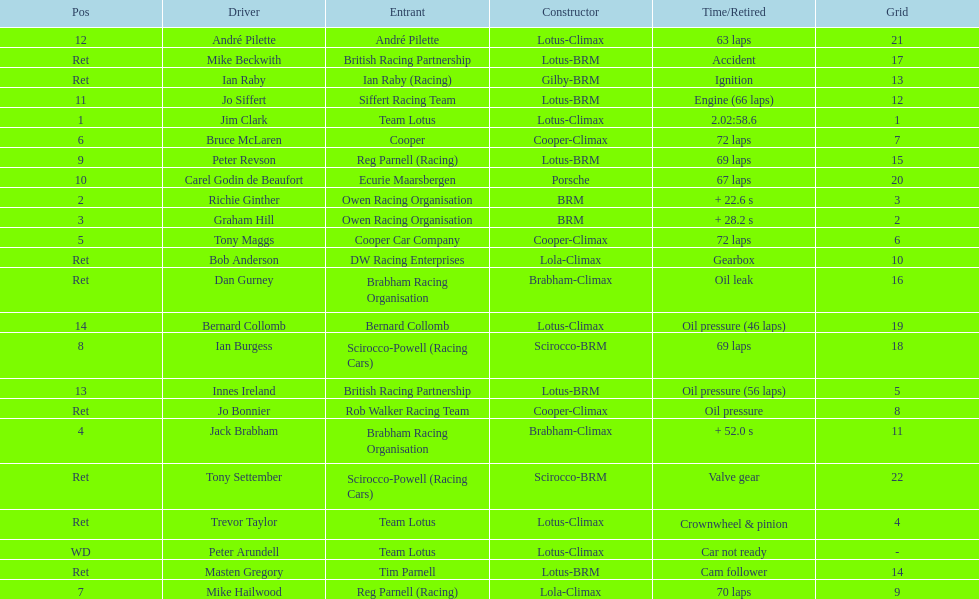What is the number of americans in the top 5? 1. 